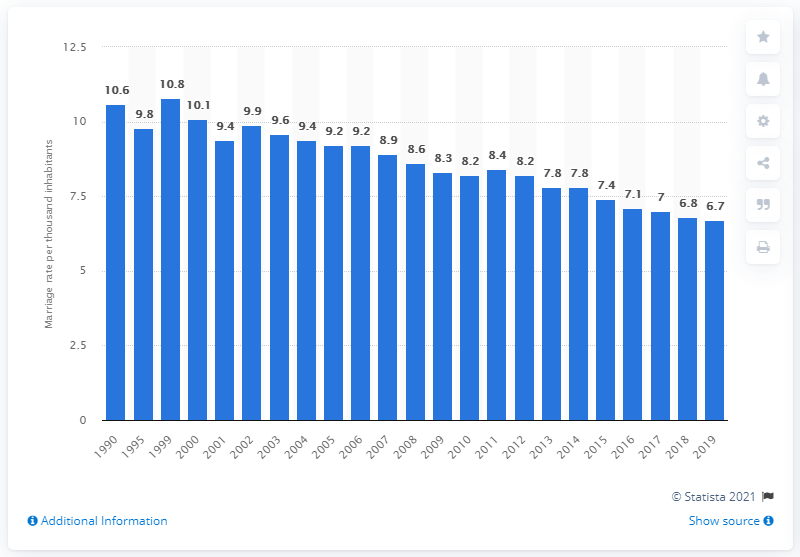Mention a couple of crucial points in this snapshot. In 2019, Alabama's marriage rate per 1,000 people was 6.7. 